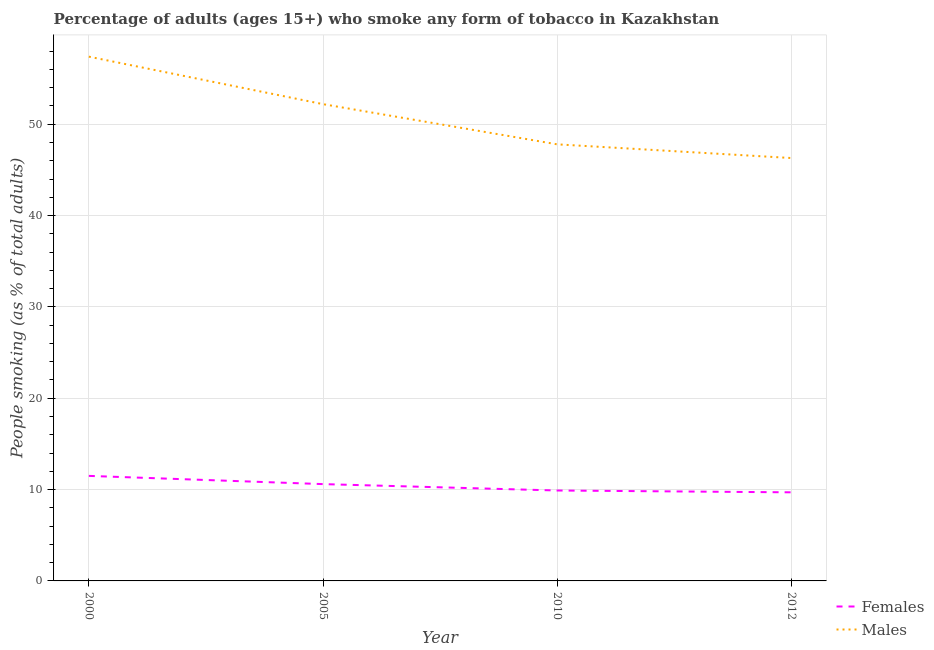Is the number of lines equal to the number of legend labels?
Make the answer very short. Yes. What is the percentage of males who smoke in 2012?
Provide a succinct answer. 46.3. Across all years, what is the maximum percentage of males who smoke?
Your response must be concise. 57.4. Across all years, what is the minimum percentage of males who smoke?
Make the answer very short. 46.3. What is the total percentage of males who smoke in the graph?
Keep it short and to the point. 203.7. What is the difference between the percentage of males who smoke in 2005 and that in 2012?
Your answer should be compact. 5.9. What is the difference between the percentage of females who smoke in 2010 and the percentage of males who smoke in 2000?
Offer a terse response. -47.5. What is the average percentage of males who smoke per year?
Your answer should be compact. 50.92. In the year 2010, what is the difference between the percentage of males who smoke and percentage of females who smoke?
Offer a terse response. 37.9. What is the ratio of the percentage of males who smoke in 2000 to that in 2010?
Ensure brevity in your answer.  1.2. What is the difference between the highest and the second highest percentage of males who smoke?
Provide a short and direct response. 5.2. What is the difference between the highest and the lowest percentage of males who smoke?
Provide a short and direct response. 11.1. In how many years, is the percentage of females who smoke greater than the average percentage of females who smoke taken over all years?
Keep it short and to the point. 2. Is the percentage of females who smoke strictly greater than the percentage of males who smoke over the years?
Offer a terse response. No. Does the graph contain grids?
Provide a short and direct response. Yes. Where does the legend appear in the graph?
Make the answer very short. Bottom right. What is the title of the graph?
Keep it short and to the point. Percentage of adults (ages 15+) who smoke any form of tobacco in Kazakhstan. What is the label or title of the X-axis?
Give a very brief answer. Year. What is the label or title of the Y-axis?
Keep it short and to the point. People smoking (as % of total adults). What is the People smoking (as % of total adults) of Males in 2000?
Keep it short and to the point. 57.4. What is the People smoking (as % of total adults) of Males in 2005?
Offer a terse response. 52.2. What is the People smoking (as % of total adults) in Females in 2010?
Keep it short and to the point. 9.9. What is the People smoking (as % of total adults) in Males in 2010?
Make the answer very short. 47.8. What is the People smoking (as % of total adults) of Females in 2012?
Give a very brief answer. 9.7. What is the People smoking (as % of total adults) in Males in 2012?
Offer a very short reply. 46.3. Across all years, what is the maximum People smoking (as % of total adults) of Females?
Make the answer very short. 11.5. Across all years, what is the maximum People smoking (as % of total adults) in Males?
Keep it short and to the point. 57.4. Across all years, what is the minimum People smoking (as % of total adults) in Females?
Provide a short and direct response. 9.7. Across all years, what is the minimum People smoking (as % of total adults) in Males?
Your response must be concise. 46.3. What is the total People smoking (as % of total adults) of Females in the graph?
Offer a very short reply. 41.7. What is the total People smoking (as % of total adults) of Males in the graph?
Make the answer very short. 203.7. What is the difference between the People smoking (as % of total adults) of Females in 2000 and that in 2005?
Offer a terse response. 0.9. What is the difference between the People smoking (as % of total adults) of Males in 2000 and that in 2010?
Offer a terse response. 9.6. What is the difference between the People smoking (as % of total adults) of Females in 2000 and that in 2012?
Your answer should be very brief. 1.8. What is the difference between the People smoking (as % of total adults) of Males in 2000 and that in 2012?
Your response must be concise. 11.1. What is the difference between the People smoking (as % of total adults) of Females in 2005 and that in 2012?
Offer a very short reply. 0.9. What is the difference between the People smoking (as % of total adults) of Males in 2010 and that in 2012?
Your response must be concise. 1.5. What is the difference between the People smoking (as % of total adults) in Females in 2000 and the People smoking (as % of total adults) in Males in 2005?
Ensure brevity in your answer.  -40.7. What is the difference between the People smoking (as % of total adults) in Females in 2000 and the People smoking (as % of total adults) in Males in 2010?
Provide a succinct answer. -36.3. What is the difference between the People smoking (as % of total adults) of Females in 2000 and the People smoking (as % of total adults) of Males in 2012?
Your answer should be very brief. -34.8. What is the difference between the People smoking (as % of total adults) of Females in 2005 and the People smoking (as % of total adults) of Males in 2010?
Ensure brevity in your answer.  -37.2. What is the difference between the People smoking (as % of total adults) in Females in 2005 and the People smoking (as % of total adults) in Males in 2012?
Keep it short and to the point. -35.7. What is the difference between the People smoking (as % of total adults) in Females in 2010 and the People smoking (as % of total adults) in Males in 2012?
Ensure brevity in your answer.  -36.4. What is the average People smoking (as % of total adults) in Females per year?
Ensure brevity in your answer.  10.43. What is the average People smoking (as % of total adults) of Males per year?
Your answer should be compact. 50.92. In the year 2000, what is the difference between the People smoking (as % of total adults) in Females and People smoking (as % of total adults) in Males?
Your response must be concise. -45.9. In the year 2005, what is the difference between the People smoking (as % of total adults) in Females and People smoking (as % of total adults) in Males?
Offer a terse response. -41.6. In the year 2010, what is the difference between the People smoking (as % of total adults) of Females and People smoking (as % of total adults) of Males?
Provide a succinct answer. -37.9. In the year 2012, what is the difference between the People smoking (as % of total adults) of Females and People smoking (as % of total adults) of Males?
Your answer should be compact. -36.6. What is the ratio of the People smoking (as % of total adults) of Females in 2000 to that in 2005?
Offer a terse response. 1.08. What is the ratio of the People smoking (as % of total adults) of Males in 2000 to that in 2005?
Provide a short and direct response. 1.1. What is the ratio of the People smoking (as % of total adults) in Females in 2000 to that in 2010?
Ensure brevity in your answer.  1.16. What is the ratio of the People smoking (as % of total adults) in Males in 2000 to that in 2010?
Offer a very short reply. 1.2. What is the ratio of the People smoking (as % of total adults) of Females in 2000 to that in 2012?
Make the answer very short. 1.19. What is the ratio of the People smoking (as % of total adults) of Males in 2000 to that in 2012?
Ensure brevity in your answer.  1.24. What is the ratio of the People smoking (as % of total adults) of Females in 2005 to that in 2010?
Make the answer very short. 1.07. What is the ratio of the People smoking (as % of total adults) of Males in 2005 to that in 2010?
Keep it short and to the point. 1.09. What is the ratio of the People smoking (as % of total adults) in Females in 2005 to that in 2012?
Offer a terse response. 1.09. What is the ratio of the People smoking (as % of total adults) in Males in 2005 to that in 2012?
Provide a short and direct response. 1.13. What is the ratio of the People smoking (as % of total adults) in Females in 2010 to that in 2012?
Give a very brief answer. 1.02. What is the ratio of the People smoking (as % of total adults) in Males in 2010 to that in 2012?
Provide a short and direct response. 1.03. What is the difference between the highest and the lowest People smoking (as % of total adults) in Females?
Ensure brevity in your answer.  1.8. 